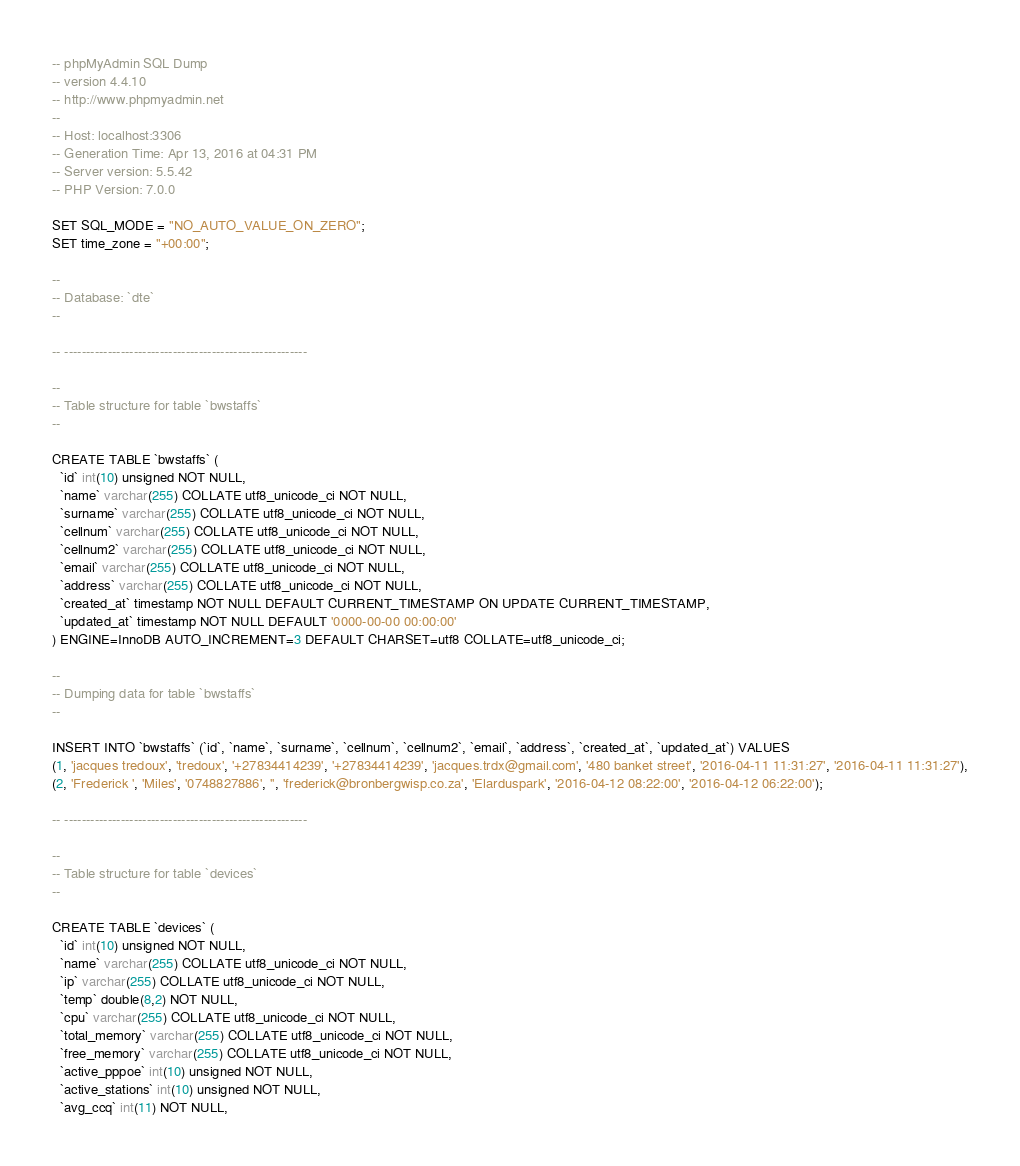<code> <loc_0><loc_0><loc_500><loc_500><_SQL_>-- phpMyAdmin SQL Dump
-- version 4.4.10
-- http://www.phpmyadmin.net
--
-- Host: localhost:3306
-- Generation Time: Apr 13, 2016 at 04:31 PM
-- Server version: 5.5.42
-- PHP Version: 7.0.0

SET SQL_MODE = "NO_AUTO_VALUE_ON_ZERO";
SET time_zone = "+00:00";

--
-- Database: `dte`
--

-- --------------------------------------------------------

--
-- Table structure for table `bwstaffs`
--

CREATE TABLE `bwstaffs` (
  `id` int(10) unsigned NOT NULL,
  `name` varchar(255) COLLATE utf8_unicode_ci NOT NULL,
  `surname` varchar(255) COLLATE utf8_unicode_ci NOT NULL,
  `cellnum` varchar(255) COLLATE utf8_unicode_ci NOT NULL,
  `cellnum2` varchar(255) COLLATE utf8_unicode_ci NOT NULL,
  `email` varchar(255) COLLATE utf8_unicode_ci NOT NULL,
  `address` varchar(255) COLLATE utf8_unicode_ci NOT NULL,
  `created_at` timestamp NOT NULL DEFAULT CURRENT_TIMESTAMP ON UPDATE CURRENT_TIMESTAMP,
  `updated_at` timestamp NOT NULL DEFAULT '0000-00-00 00:00:00'
) ENGINE=InnoDB AUTO_INCREMENT=3 DEFAULT CHARSET=utf8 COLLATE=utf8_unicode_ci;

--
-- Dumping data for table `bwstaffs`
--

INSERT INTO `bwstaffs` (`id`, `name`, `surname`, `cellnum`, `cellnum2`, `email`, `address`, `created_at`, `updated_at`) VALUES
(1, 'jacques tredoux', 'tredoux', '+27834414239', '+27834414239', 'jacques.trdx@gmail.com', '480 banket street', '2016-04-11 11:31:27', '2016-04-11 11:31:27'),
(2, 'Frederick ', 'Miles', '0748827886', '', 'frederick@bronbergwisp.co.za', 'Elarduspark', '2016-04-12 08:22:00', '2016-04-12 06:22:00');

-- --------------------------------------------------------

--
-- Table structure for table `devices`
--

CREATE TABLE `devices` (
  `id` int(10) unsigned NOT NULL,
  `name` varchar(255) COLLATE utf8_unicode_ci NOT NULL,
  `ip` varchar(255) COLLATE utf8_unicode_ci NOT NULL,
  `temp` double(8,2) NOT NULL,
  `cpu` varchar(255) COLLATE utf8_unicode_ci NOT NULL,
  `total_memory` varchar(255) COLLATE utf8_unicode_ci NOT NULL,
  `free_memory` varchar(255) COLLATE utf8_unicode_ci NOT NULL,
  `active_pppoe` int(10) unsigned NOT NULL,
  `active_stations` int(10) unsigned NOT NULL,
  `avg_ccq` int(11) NOT NULL,</code> 